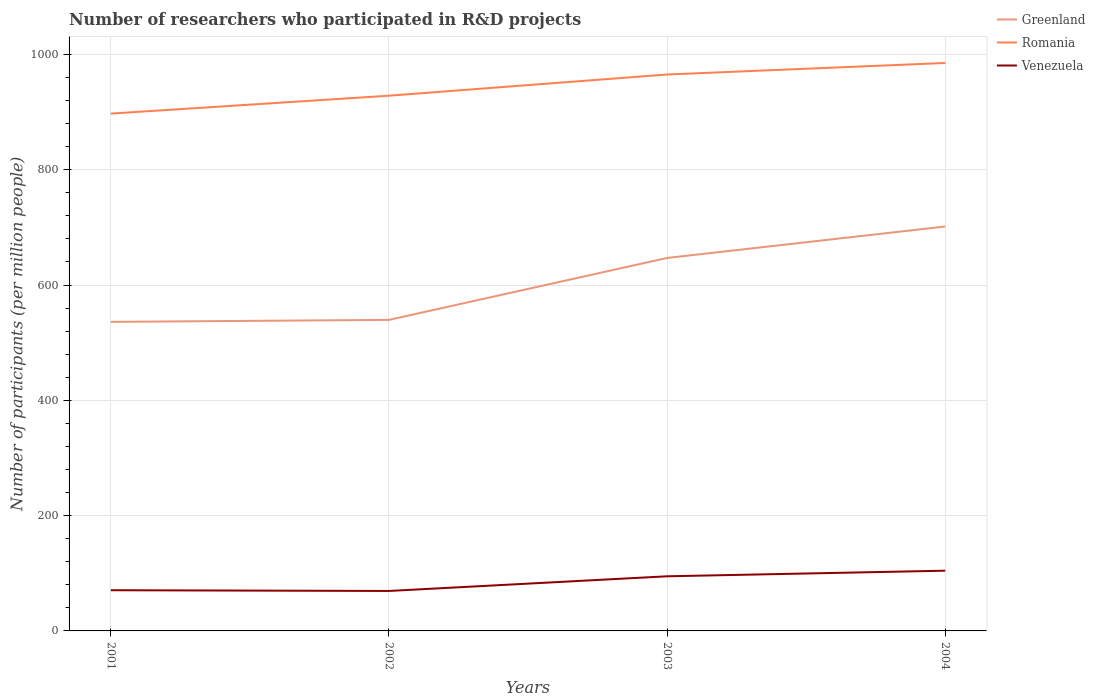Is the number of lines equal to the number of legend labels?
Give a very brief answer. Yes. Across all years, what is the maximum number of researchers who participated in R&D projects in Greenland?
Your answer should be compact. 536.06. What is the total number of researchers who participated in R&D projects in Greenland in the graph?
Provide a short and direct response. -3.44. What is the difference between the highest and the second highest number of researchers who participated in R&D projects in Greenland?
Offer a very short reply. 165.4. Is the number of researchers who participated in R&D projects in Venezuela strictly greater than the number of researchers who participated in R&D projects in Romania over the years?
Keep it short and to the point. Yes. How many lines are there?
Your answer should be compact. 3. How many years are there in the graph?
Your answer should be compact. 4. Does the graph contain grids?
Make the answer very short. Yes. Where does the legend appear in the graph?
Offer a very short reply. Top right. How many legend labels are there?
Your answer should be compact. 3. How are the legend labels stacked?
Make the answer very short. Vertical. What is the title of the graph?
Ensure brevity in your answer.  Number of researchers who participated in R&D projects. Does "Middle East & North Africa (developing only)" appear as one of the legend labels in the graph?
Provide a succinct answer. No. What is the label or title of the Y-axis?
Make the answer very short. Number of participants (per million people). What is the Number of participants (per million people) of Greenland in 2001?
Your answer should be very brief. 536.06. What is the Number of participants (per million people) of Romania in 2001?
Your answer should be very brief. 897.32. What is the Number of participants (per million people) in Venezuela in 2001?
Provide a short and direct response. 70.61. What is the Number of participants (per million people) in Greenland in 2002?
Make the answer very short. 539.5. What is the Number of participants (per million people) of Romania in 2002?
Your answer should be compact. 928.34. What is the Number of participants (per million people) in Venezuela in 2002?
Offer a terse response. 69.33. What is the Number of participants (per million people) in Greenland in 2003?
Give a very brief answer. 646.9. What is the Number of participants (per million people) of Romania in 2003?
Your answer should be compact. 965.12. What is the Number of participants (per million people) in Venezuela in 2003?
Provide a short and direct response. 94.75. What is the Number of participants (per million people) of Greenland in 2004?
Your answer should be compact. 701.46. What is the Number of participants (per million people) in Romania in 2004?
Give a very brief answer. 985.11. What is the Number of participants (per million people) in Venezuela in 2004?
Make the answer very short. 104.47. Across all years, what is the maximum Number of participants (per million people) of Greenland?
Your response must be concise. 701.46. Across all years, what is the maximum Number of participants (per million people) of Romania?
Provide a succinct answer. 985.11. Across all years, what is the maximum Number of participants (per million people) in Venezuela?
Your answer should be very brief. 104.47. Across all years, what is the minimum Number of participants (per million people) of Greenland?
Your answer should be very brief. 536.06. Across all years, what is the minimum Number of participants (per million people) of Romania?
Offer a very short reply. 897.32. Across all years, what is the minimum Number of participants (per million people) of Venezuela?
Your answer should be compact. 69.33. What is the total Number of participants (per million people) in Greenland in the graph?
Provide a short and direct response. 2423.92. What is the total Number of participants (per million people) of Romania in the graph?
Your answer should be compact. 3775.89. What is the total Number of participants (per million people) in Venezuela in the graph?
Provide a succinct answer. 339.16. What is the difference between the Number of participants (per million people) in Greenland in 2001 and that in 2002?
Your response must be concise. -3.44. What is the difference between the Number of participants (per million people) of Romania in 2001 and that in 2002?
Offer a terse response. -31.02. What is the difference between the Number of participants (per million people) in Venezuela in 2001 and that in 2002?
Keep it short and to the point. 1.28. What is the difference between the Number of participants (per million people) in Greenland in 2001 and that in 2003?
Offer a very short reply. -110.84. What is the difference between the Number of participants (per million people) in Romania in 2001 and that in 2003?
Provide a succinct answer. -67.8. What is the difference between the Number of participants (per million people) of Venezuela in 2001 and that in 2003?
Your response must be concise. -24.14. What is the difference between the Number of participants (per million people) in Greenland in 2001 and that in 2004?
Your answer should be compact. -165.4. What is the difference between the Number of participants (per million people) in Romania in 2001 and that in 2004?
Offer a terse response. -87.79. What is the difference between the Number of participants (per million people) of Venezuela in 2001 and that in 2004?
Offer a terse response. -33.86. What is the difference between the Number of participants (per million people) of Greenland in 2002 and that in 2003?
Give a very brief answer. -107.4. What is the difference between the Number of participants (per million people) of Romania in 2002 and that in 2003?
Keep it short and to the point. -36.78. What is the difference between the Number of participants (per million people) of Venezuela in 2002 and that in 2003?
Offer a very short reply. -25.42. What is the difference between the Number of participants (per million people) of Greenland in 2002 and that in 2004?
Keep it short and to the point. -161.97. What is the difference between the Number of participants (per million people) of Romania in 2002 and that in 2004?
Your answer should be compact. -56.77. What is the difference between the Number of participants (per million people) in Venezuela in 2002 and that in 2004?
Provide a succinct answer. -35.13. What is the difference between the Number of participants (per million people) of Greenland in 2003 and that in 2004?
Provide a succinct answer. -54.56. What is the difference between the Number of participants (per million people) in Romania in 2003 and that in 2004?
Provide a short and direct response. -19.99. What is the difference between the Number of participants (per million people) in Venezuela in 2003 and that in 2004?
Make the answer very short. -9.72. What is the difference between the Number of participants (per million people) of Greenland in 2001 and the Number of participants (per million people) of Romania in 2002?
Ensure brevity in your answer.  -392.28. What is the difference between the Number of participants (per million people) in Greenland in 2001 and the Number of participants (per million people) in Venezuela in 2002?
Provide a short and direct response. 466.73. What is the difference between the Number of participants (per million people) of Romania in 2001 and the Number of participants (per million people) of Venezuela in 2002?
Make the answer very short. 827.99. What is the difference between the Number of participants (per million people) in Greenland in 2001 and the Number of participants (per million people) in Romania in 2003?
Keep it short and to the point. -429.06. What is the difference between the Number of participants (per million people) of Greenland in 2001 and the Number of participants (per million people) of Venezuela in 2003?
Your answer should be very brief. 441.31. What is the difference between the Number of participants (per million people) of Romania in 2001 and the Number of participants (per million people) of Venezuela in 2003?
Make the answer very short. 802.57. What is the difference between the Number of participants (per million people) of Greenland in 2001 and the Number of participants (per million people) of Romania in 2004?
Provide a short and direct response. -449.05. What is the difference between the Number of participants (per million people) of Greenland in 2001 and the Number of participants (per million people) of Venezuela in 2004?
Your answer should be very brief. 431.59. What is the difference between the Number of participants (per million people) in Romania in 2001 and the Number of participants (per million people) in Venezuela in 2004?
Your answer should be compact. 792.85. What is the difference between the Number of participants (per million people) in Greenland in 2002 and the Number of participants (per million people) in Romania in 2003?
Provide a succinct answer. -425.62. What is the difference between the Number of participants (per million people) of Greenland in 2002 and the Number of participants (per million people) of Venezuela in 2003?
Your answer should be compact. 444.75. What is the difference between the Number of participants (per million people) of Romania in 2002 and the Number of participants (per million people) of Venezuela in 2003?
Provide a succinct answer. 833.59. What is the difference between the Number of participants (per million people) of Greenland in 2002 and the Number of participants (per million people) of Romania in 2004?
Keep it short and to the point. -445.61. What is the difference between the Number of participants (per million people) in Greenland in 2002 and the Number of participants (per million people) in Venezuela in 2004?
Offer a terse response. 435.03. What is the difference between the Number of participants (per million people) in Romania in 2002 and the Number of participants (per million people) in Venezuela in 2004?
Offer a very short reply. 823.87. What is the difference between the Number of participants (per million people) of Greenland in 2003 and the Number of participants (per million people) of Romania in 2004?
Provide a short and direct response. -338.21. What is the difference between the Number of participants (per million people) of Greenland in 2003 and the Number of participants (per million people) of Venezuela in 2004?
Provide a short and direct response. 542.43. What is the difference between the Number of participants (per million people) of Romania in 2003 and the Number of participants (per million people) of Venezuela in 2004?
Provide a succinct answer. 860.65. What is the average Number of participants (per million people) in Greenland per year?
Give a very brief answer. 605.98. What is the average Number of participants (per million people) of Romania per year?
Offer a very short reply. 943.97. What is the average Number of participants (per million people) of Venezuela per year?
Your answer should be very brief. 84.79. In the year 2001, what is the difference between the Number of participants (per million people) in Greenland and Number of participants (per million people) in Romania?
Provide a short and direct response. -361.26. In the year 2001, what is the difference between the Number of participants (per million people) of Greenland and Number of participants (per million people) of Venezuela?
Your response must be concise. 465.45. In the year 2001, what is the difference between the Number of participants (per million people) in Romania and Number of participants (per million people) in Venezuela?
Offer a terse response. 826.71. In the year 2002, what is the difference between the Number of participants (per million people) of Greenland and Number of participants (per million people) of Romania?
Offer a very short reply. -388.84. In the year 2002, what is the difference between the Number of participants (per million people) in Greenland and Number of participants (per million people) in Venezuela?
Provide a short and direct response. 470.17. In the year 2002, what is the difference between the Number of participants (per million people) in Romania and Number of participants (per million people) in Venezuela?
Offer a very short reply. 859. In the year 2003, what is the difference between the Number of participants (per million people) of Greenland and Number of participants (per million people) of Romania?
Your response must be concise. -318.22. In the year 2003, what is the difference between the Number of participants (per million people) in Greenland and Number of participants (per million people) in Venezuela?
Provide a short and direct response. 552.15. In the year 2003, what is the difference between the Number of participants (per million people) of Romania and Number of participants (per million people) of Venezuela?
Your response must be concise. 870.37. In the year 2004, what is the difference between the Number of participants (per million people) of Greenland and Number of participants (per million people) of Romania?
Provide a short and direct response. -283.64. In the year 2004, what is the difference between the Number of participants (per million people) in Greenland and Number of participants (per million people) in Venezuela?
Ensure brevity in your answer.  597. In the year 2004, what is the difference between the Number of participants (per million people) in Romania and Number of participants (per million people) in Venezuela?
Your answer should be very brief. 880.64. What is the ratio of the Number of participants (per million people) in Greenland in 2001 to that in 2002?
Your answer should be compact. 0.99. What is the ratio of the Number of participants (per million people) of Romania in 2001 to that in 2002?
Give a very brief answer. 0.97. What is the ratio of the Number of participants (per million people) of Venezuela in 2001 to that in 2002?
Your answer should be compact. 1.02. What is the ratio of the Number of participants (per million people) in Greenland in 2001 to that in 2003?
Your answer should be compact. 0.83. What is the ratio of the Number of participants (per million people) of Romania in 2001 to that in 2003?
Your answer should be very brief. 0.93. What is the ratio of the Number of participants (per million people) in Venezuela in 2001 to that in 2003?
Make the answer very short. 0.75. What is the ratio of the Number of participants (per million people) of Greenland in 2001 to that in 2004?
Offer a terse response. 0.76. What is the ratio of the Number of participants (per million people) of Romania in 2001 to that in 2004?
Give a very brief answer. 0.91. What is the ratio of the Number of participants (per million people) of Venezuela in 2001 to that in 2004?
Make the answer very short. 0.68. What is the ratio of the Number of participants (per million people) in Greenland in 2002 to that in 2003?
Your answer should be compact. 0.83. What is the ratio of the Number of participants (per million people) of Romania in 2002 to that in 2003?
Your answer should be very brief. 0.96. What is the ratio of the Number of participants (per million people) in Venezuela in 2002 to that in 2003?
Your answer should be compact. 0.73. What is the ratio of the Number of participants (per million people) of Greenland in 2002 to that in 2004?
Ensure brevity in your answer.  0.77. What is the ratio of the Number of participants (per million people) in Romania in 2002 to that in 2004?
Keep it short and to the point. 0.94. What is the ratio of the Number of participants (per million people) in Venezuela in 2002 to that in 2004?
Give a very brief answer. 0.66. What is the ratio of the Number of participants (per million people) in Greenland in 2003 to that in 2004?
Ensure brevity in your answer.  0.92. What is the ratio of the Number of participants (per million people) of Romania in 2003 to that in 2004?
Keep it short and to the point. 0.98. What is the ratio of the Number of participants (per million people) of Venezuela in 2003 to that in 2004?
Your response must be concise. 0.91. What is the difference between the highest and the second highest Number of participants (per million people) in Greenland?
Offer a very short reply. 54.56. What is the difference between the highest and the second highest Number of participants (per million people) in Romania?
Give a very brief answer. 19.99. What is the difference between the highest and the second highest Number of participants (per million people) of Venezuela?
Offer a terse response. 9.72. What is the difference between the highest and the lowest Number of participants (per million people) in Greenland?
Ensure brevity in your answer.  165.4. What is the difference between the highest and the lowest Number of participants (per million people) in Romania?
Give a very brief answer. 87.79. What is the difference between the highest and the lowest Number of participants (per million people) in Venezuela?
Offer a terse response. 35.13. 